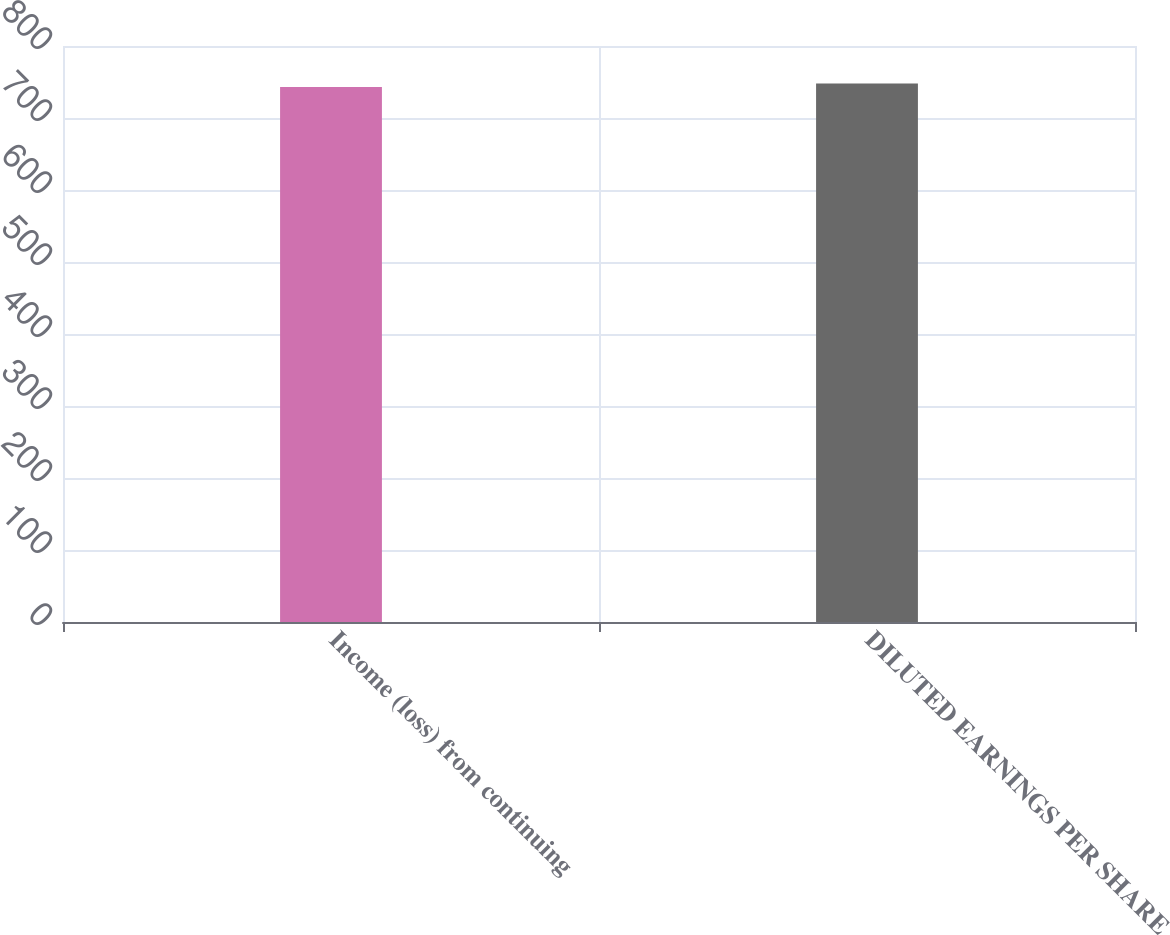<chart> <loc_0><loc_0><loc_500><loc_500><bar_chart><fcel>Income (loss) from continuing<fcel>DILUTED EARNINGS PER SHARE<nl><fcel>743<fcel>748<nl></chart> 